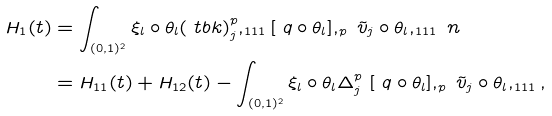<formula> <loc_0><loc_0><loc_500><loc_500>H _ { 1 } ( t ) & = \int _ { ( 0 , 1 ) ^ { 2 } } \xi _ { l } \circ \theta _ { l } ( \ t b k ) _ { j } ^ { p } , _ { 1 1 1 } [ \ q \circ \theta _ { l } ] , _ { p } \ { \tilde { v } } _ { j } \circ \theta _ { l } , _ { 1 1 1 } \ n \\ & = H _ { 1 1 } ( t ) + H _ { 1 2 } ( t ) - \int _ { ( 0 , 1 ) ^ { 2 } } \xi _ { l } \circ \theta _ { l } \Delta _ { j } ^ { p } \ [ \ q \circ \theta _ { l } ] , _ { p } \ { \tilde { v } } _ { j } \circ \theta _ { l } , _ { 1 1 1 } ,</formula> 